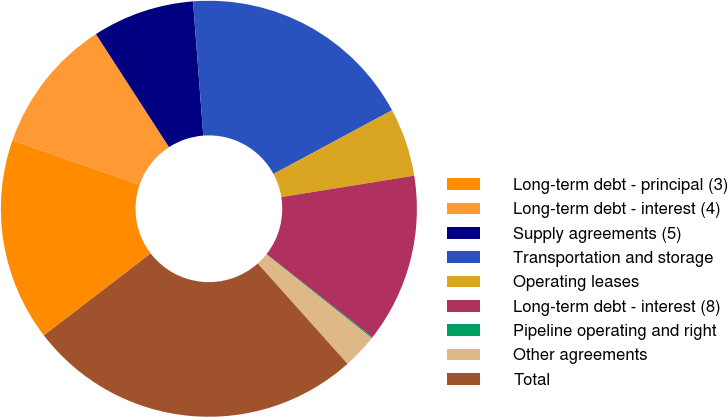Convert chart. <chart><loc_0><loc_0><loc_500><loc_500><pie_chart><fcel>Long-term debt - principal (3)<fcel>Long-term debt - interest (4)<fcel>Supply agreements (5)<fcel>Transportation and storage<fcel>Operating leases<fcel>Long-term debt - interest (8)<fcel>Pipeline operating and right<fcel>Other agreements<fcel>Total<nl><fcel>15.75%<fcel>10.53%<fcel>7.92%<fcel>18.36%<fcel>5.31%<fcel>13.14%<fcel>0.09%<fcel>2.7%<fcel>26.19%<nl></chart> 